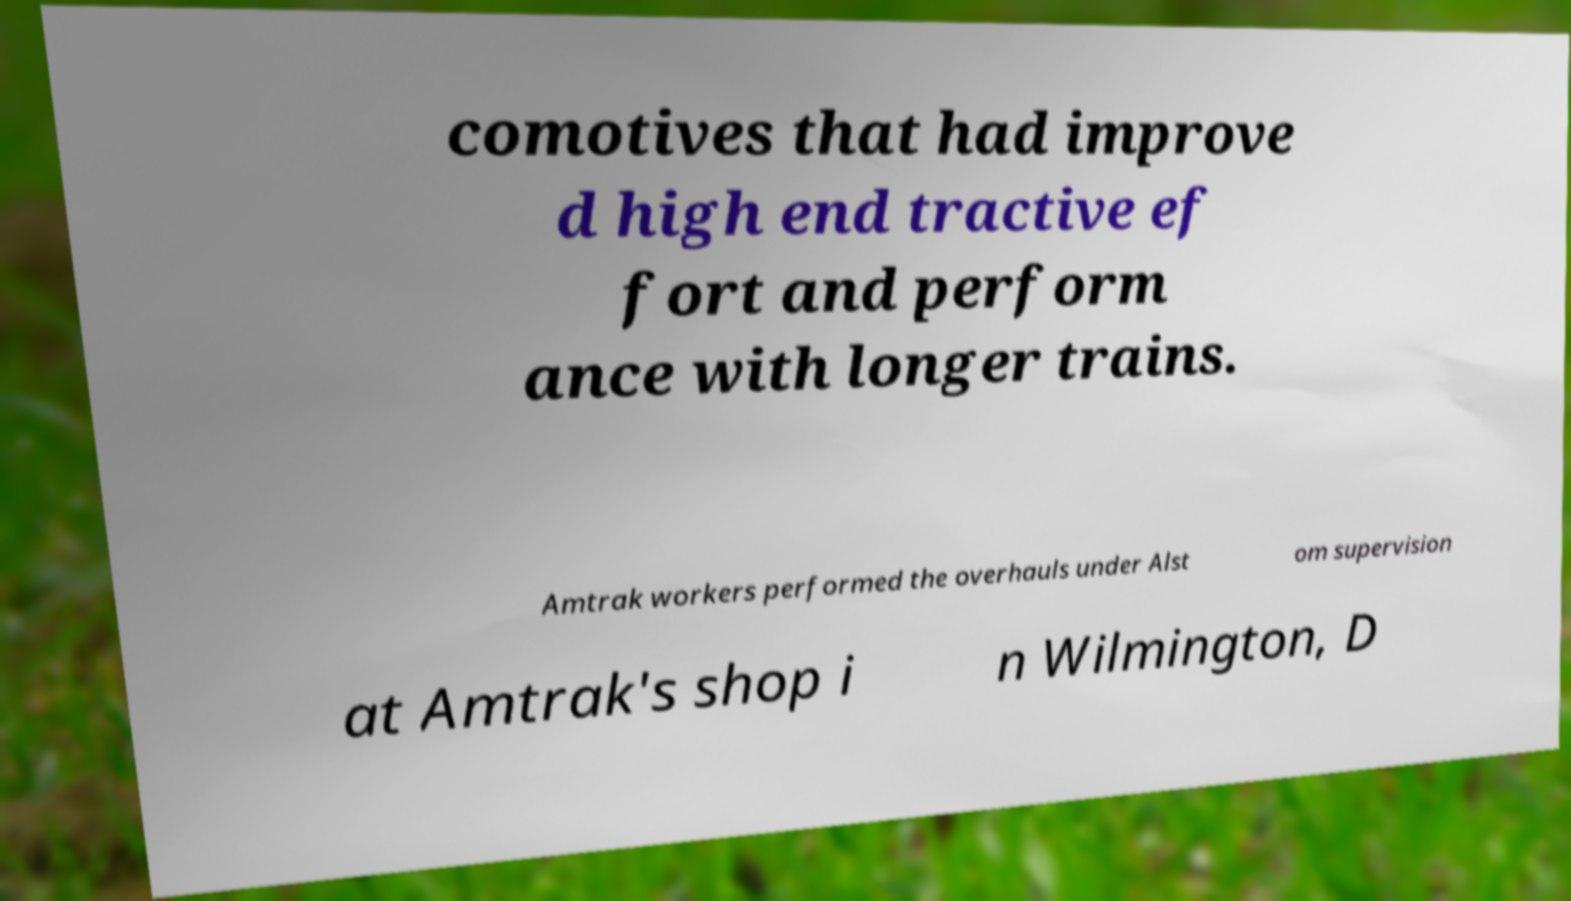What messages or text are displayed in this image? I need them in a readable, typed format. comotives that had improve d high end tractive ef fort and perform ance with longer trains. Amtrak workers performed the overhauls under Alst om supervision at Amtrak's shop i n Wilmington, D 